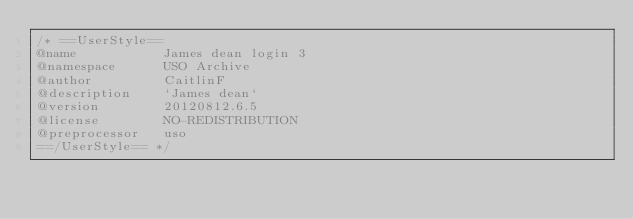<code> <loc_0><loc_0><loc_500><loc_500><_CSS_>/* ==UserStyle==
@name           James dean login 3
@namespace      USO Archive
@author         CaitlinF
@description    `James dean`
@version        20120812.6.5
@license        NO-REDISTRIBUTION
@preprocessor   uso
==/UserStyle== */</code> 